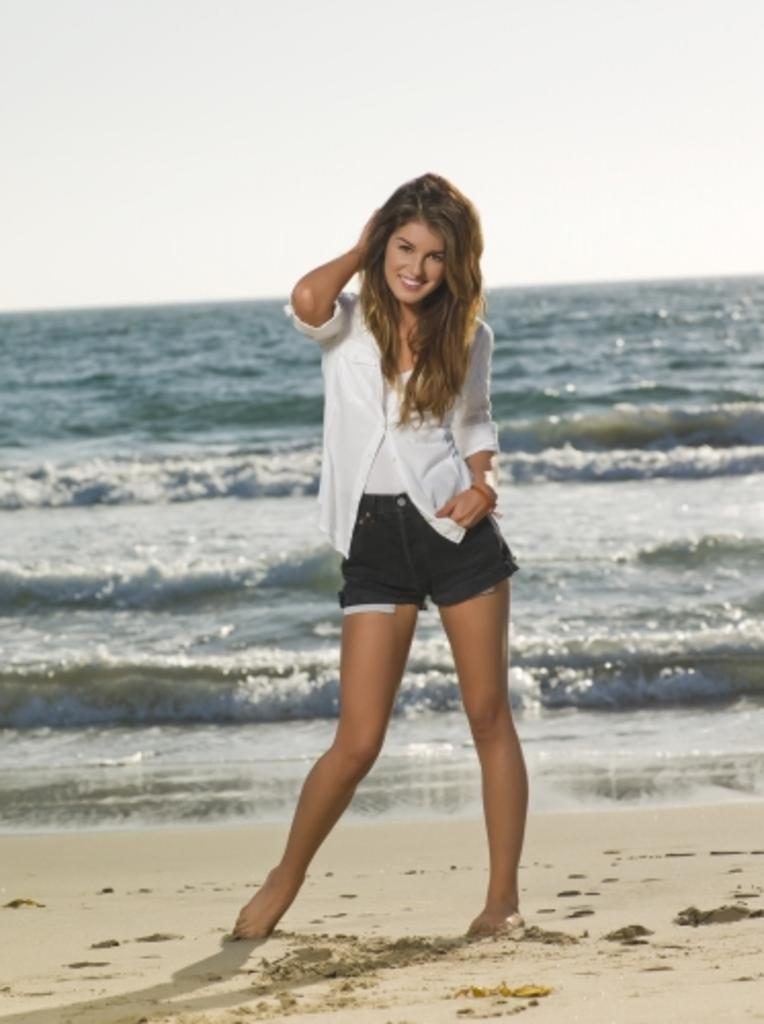Where was the image taken? The image was taken at the beach. What is the woman in the image doing? The woman is standing in the image. What is the woman's facial expression? The woman is smiling. What can be seen in the background of the image? There is water visible in the image. What structure is present in the image? There is a stand in the image. What is visible at the top of the image? The sky is visible at the top of the image. Is the woman's sister standing next to her in the image? There is no mention of a sister or anyone else standing next to the woman in the image. 